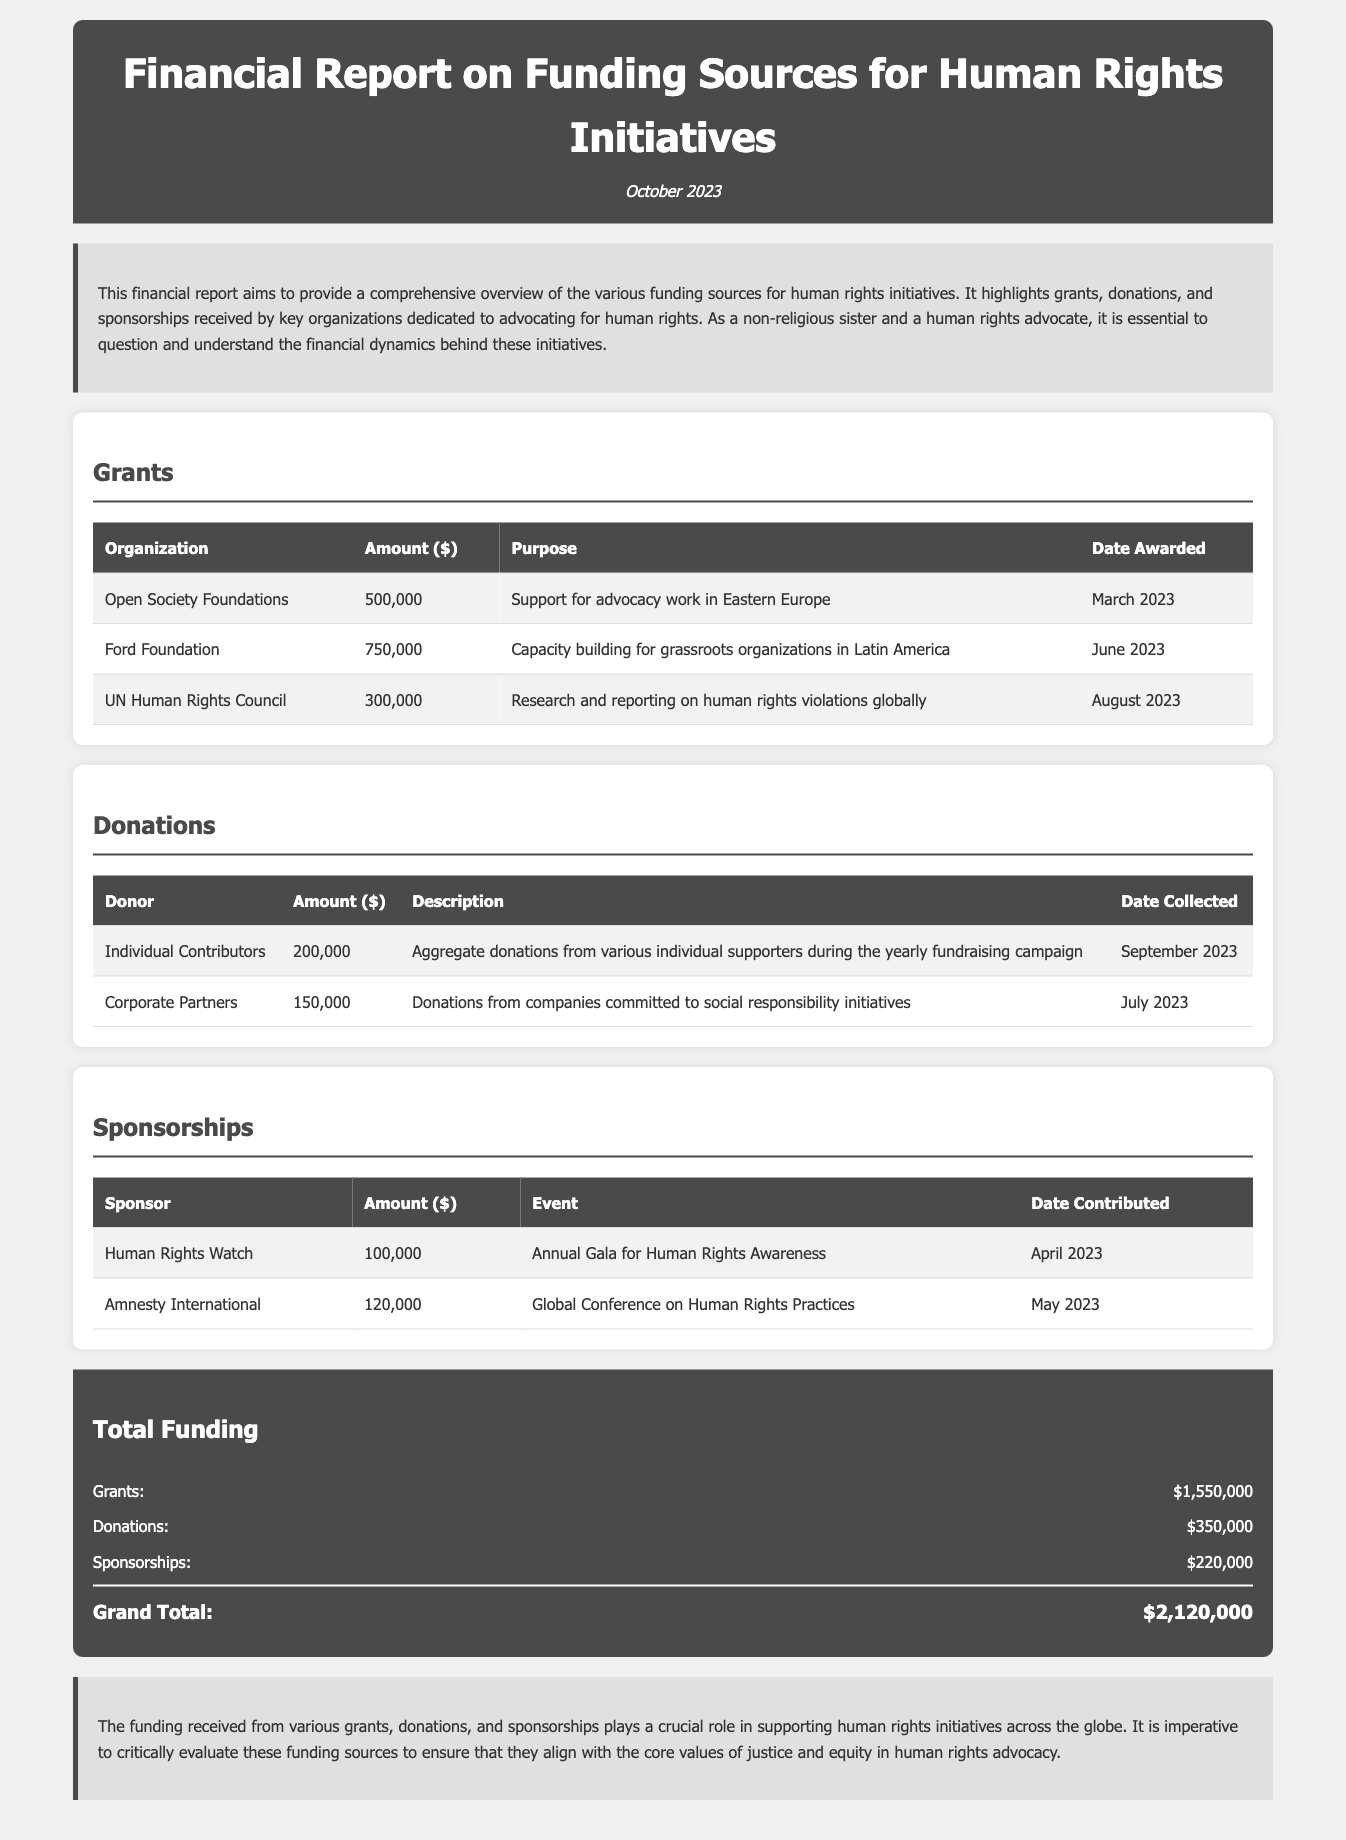What is the total amount of grants? The total amount of grants is calculated by summing the individual grant amounts listed in the document: 500,000 + 750,000 + 300,000 = 1,550,000.
Answer: 1,550,000 Who donated the aggregate sum of 200,000? The document indicates that the aggregate sum of 200,000 was collected from various individual supporters during the yearly fundraising campaign.
Answer: Individual Contributors What purpose did the Ford Foundation grant serve? The purpose of the Ford Foundation's grant is specified in the document as capacity building for grassroots organizations in Latin America.
Answer: Capacity building for grassroots organizations in Latin America How much was contributed by Amnesty International? The contribution from Amnesty International is specified in the sponsorship section of the funding report.
Answer: 120,000 When was the grant awarded by the UN Human Rights Council? The date awarded for the UN Human Rights Council grant is stated in the document.
Answer: August 2023 What are the total donations amounting to? The total donations are the sum of all individual donation amounts as detailed in the document: 200,000 + 150,000 = 350,000.
Answer: 350,000 What event did the Human Rights Watch sponsor? The document lists the Annual Gala for Human Rights Awareness as the event sponsored by Human Rights Watch.
Answer: Annual Gala for Human Rights Awareness What is the grand total of funding? The grand total of funding represents the overall sum of grants, donations, and sponsorships detailed in the report as 1,550,000 + 350,000 + 220,000 = 2,120,000.
Answer: 2,120,000 What was the primary focus of the funding report? The primary focus of the funding report is to provide an overview of the various funding sources for human rights initiatives.
Answer: Funding sources for human rights initiatives 